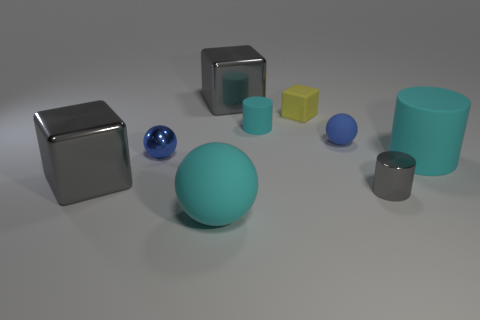What number of other objects are there of the same material as the large cyan ball?
Ensure brevity in your answer.  4. Does the tiny blue sphere that is on the right side of the large cyan rubber ball have the same material as the small cylinder that is behind the tiny gray object?
Keep it short and to the point. Yes. How many spheres are both in front of the small gray metallic cylinder and to the right of the tiny cyan matte cylinder?
Your answer should be very brief. 0. Are there any other objects that have the same shape as the yellow object?
Keep it short and to the point. Yes. What is the shape of the blue shiny thing that is the same size as the blue rubber ball?
Keep it short and to the point. Sphere. Is the number of small blue spheres that are in front of the small cyan cylinder the same as the number of shiny spheres behind the blue metallic ball?
Give a very brief answer. No. What size is the cyan object on the left side of the large block on the right side of the big rubber ball?
Make the answer very short. Large. Is there a rubber cylinder of the same size as the rubber cube?
Your answer should be compact. Yes. What is the color of the small block that is the same material as the large cyan cylinder?
Offer a very short reply. Yellow. Are there fewer blue matte things than large gray things?
Provide a succinct answer. Yes. 